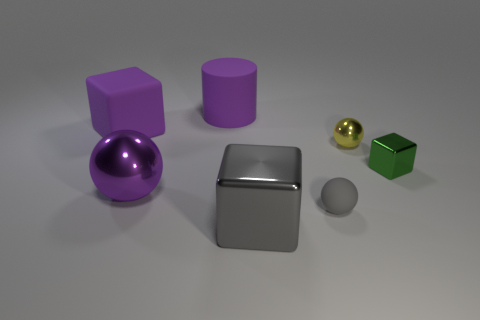What is the color of the small sphere that is the same material as the small block?
Make the answer very short. Yellow. There is a purple object that is behind the large rubber cube; how big is it?
Provide a short and direct response. Large. Are there fewer green cubes that are on the right side of the green shiny thing than metal things?
Make the answer very short. Yes. Is the cylinder the same color as the rubber block?
Offer a very short reply. Yes. Are there any other things that have the same shape as the gray shiny object?
Keep it short and to the point. Yes. Are there fewer red balls than big gray metallic objects?
Your answer should be compact. Yes. What is the color of the shiny ball behind the metal block to the right of the gray block?
Your answer should be compact. Yellow. There is a thing behind the large purple rubber object left of the large matte cylinder that is on the right side of the purple matte cube; what is its material?
Keep it short and to the point. Rubber. Is the size of the thing in front of the gray ball the same as the tiny green metal object?
Give a very brief answer. No. There is a small ball behind the small rubber sphere; what material is it?
Give a very brief answer. Metal. 